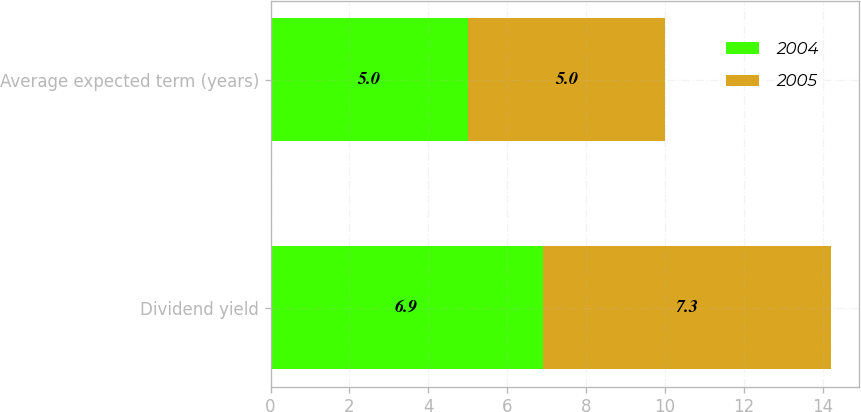Convert chart. <chart><loc_0><loc_0><loc_500><loc_500><stacked_bar_chart><ecel><fcel>Dividend yield<fcel>Average expected term (years)<nl><fcel>2004<fcel>6.9<fcel>5<nl><fcel>2005<fcel>7.3<fcel>5<nl></chart> 